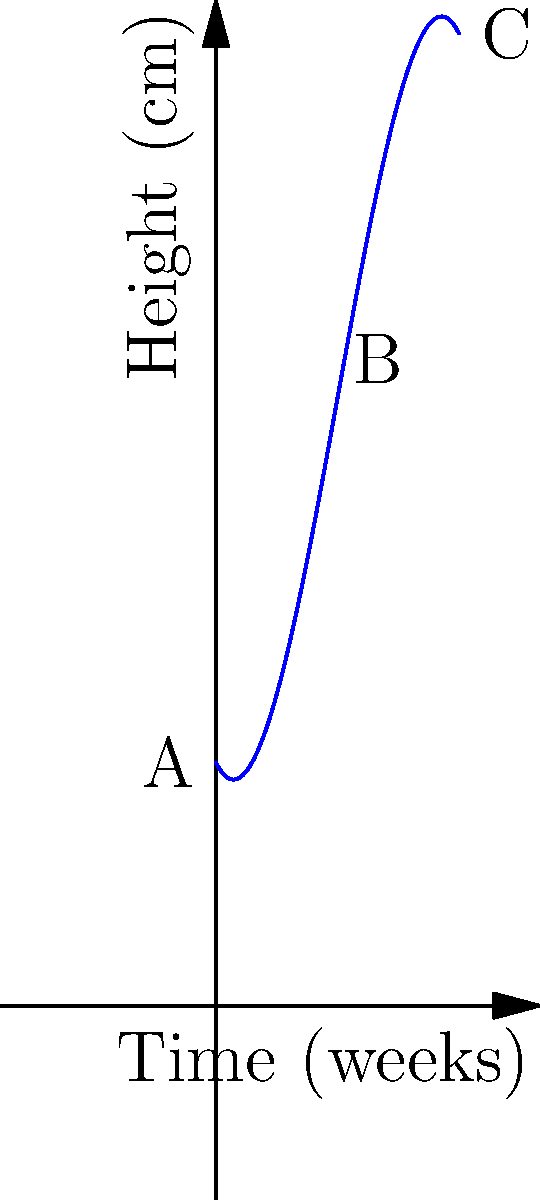As a community gardener, you're studying the growth pattern of a rare plant species. The polynomial function $f(x) = -0.1x^3 + 1.5x^2 - 2x + 10$ models the height of the plant in centimeters over time, where $x$ represents the number of weeks since planting. What is the approximate change in height of the plant between weeks 5 and 10? To find the change in height between weeks 5 and 10, we need to:

1. Calculate the height at week 5:
   $f(5) = -0.1(5^3) + 1.5(5^2) - 2(5) + 10$
   $= -12.5 + 37.5 - 10 + 10 = 25$ cm

2. Calculate the height at week 10:
   $f(10) = -0.1(10^3) + 1.5(10^2) - 2(10) + 10$
   $= -100 + 150 - 20 + 10 = 40$ cm

3. Calculate the change in height:
   Change = Height at week 10 - Height at week 5
   $= 40 - 25 = 15$ cm

The change in height between weeks 5 and 10 is approximately 15 cm.
Answer: 15 cm 